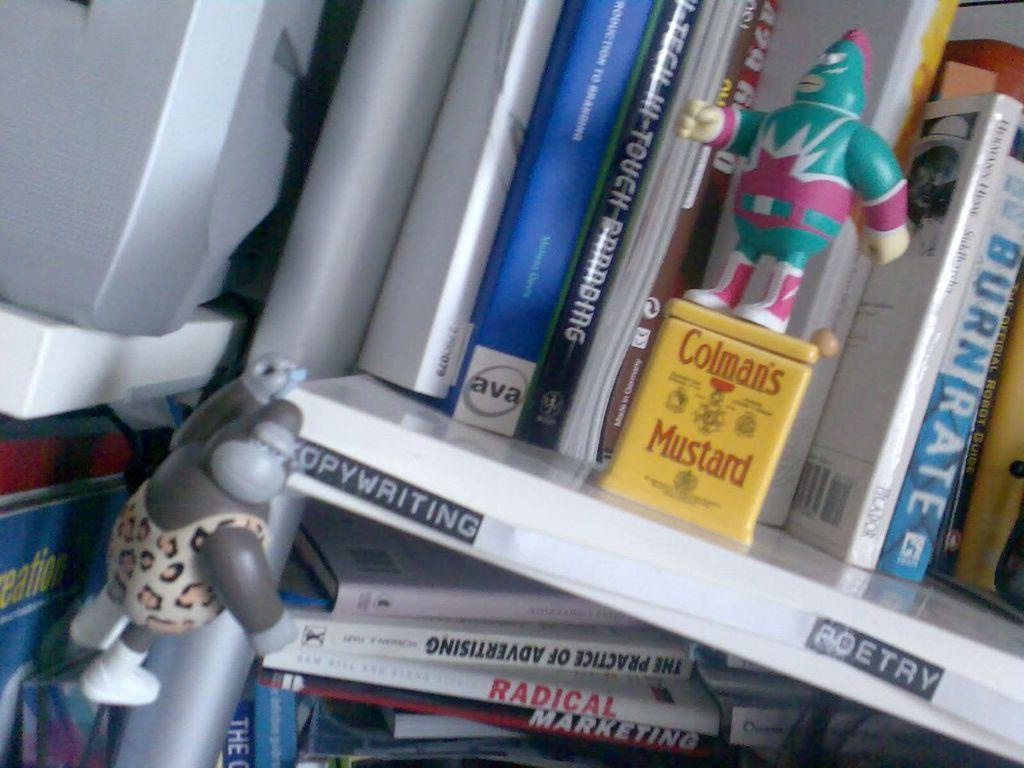Provide a one-sentence caption for the provided image. A shelf of books with labels for copywriting and poetry and a green action figure standing on a yellow Colamn's Mustard can. 